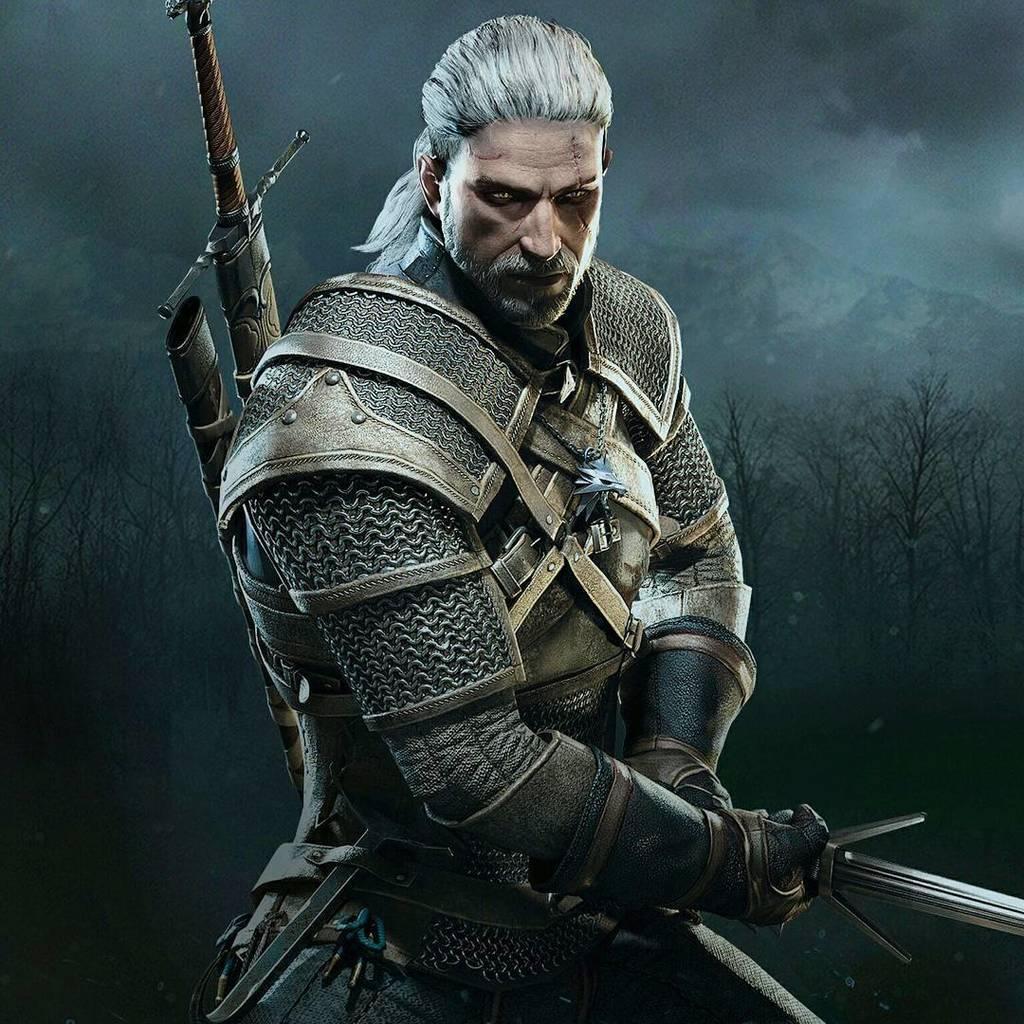Describe this image in one or two sentences. Here in this picture we can see an animation character wearing an Armour and holding a sword and carrying a sword present over there and behind it we can see trees and mountains present. 